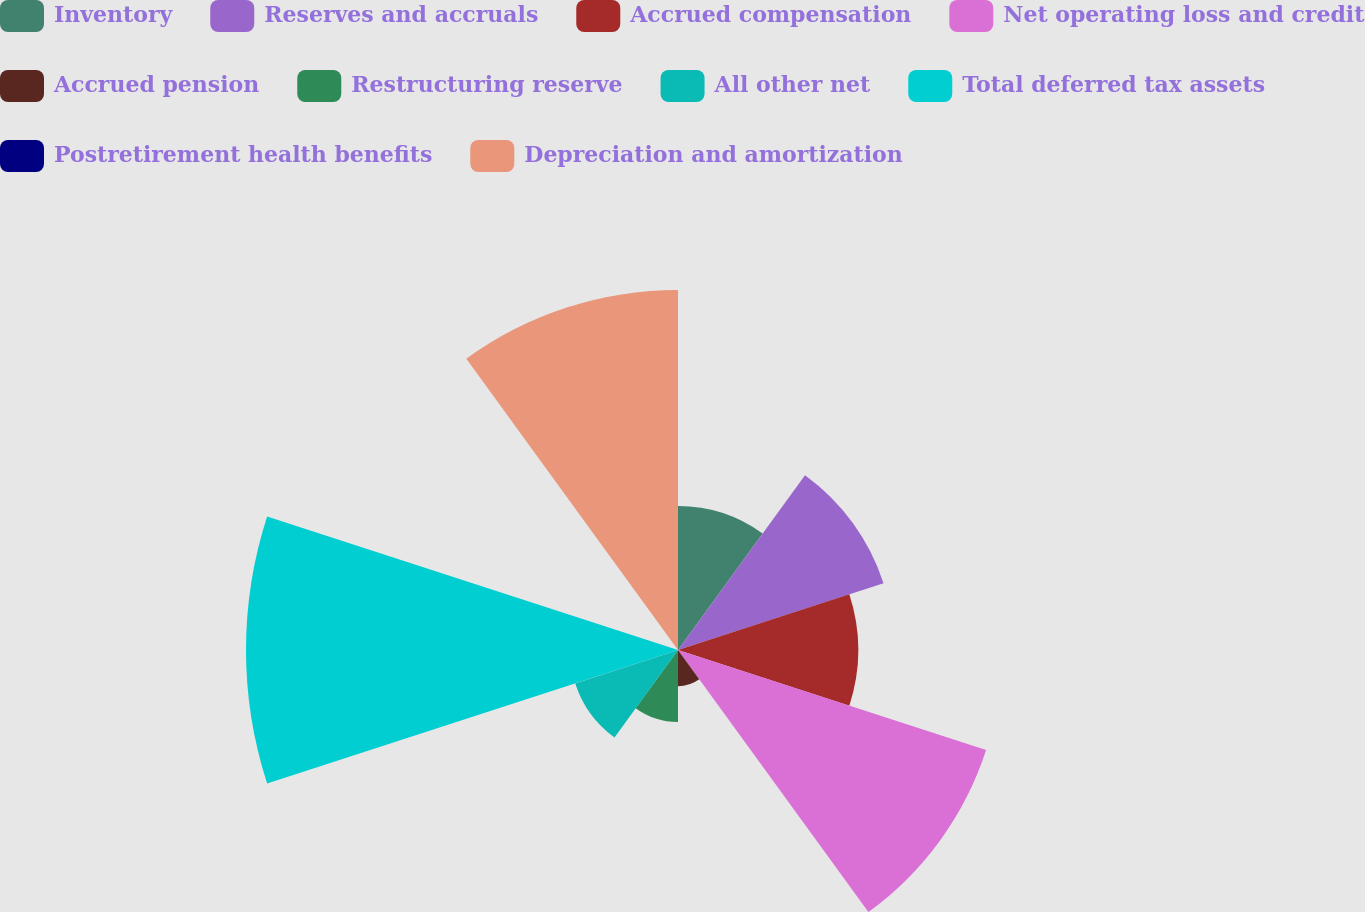Convert chart. <chart><loc_0><loc_0><loc_500><loc_500><pie_chart><fcel>Inventory<fcel>Reserves and accruals<fcel>Accrued compensation<fcel>Net operating loss and credit<fcel>Accrued pension<fcel>Restructuring reserve<fcel>All other net<fcel>Total deferred tax assets<fcel>Postretirement health benefits<fcel>Depreciation and amortization<nl><fcel>7.69%<fcel>11.54%<fcel>9.62%<fcel>17.3%<fcel>1.93%<fcel>3.85%<fcel>5.77%<fcel>23.07%<fcel>0.0%<fcel>19.23%<nl></chart> 